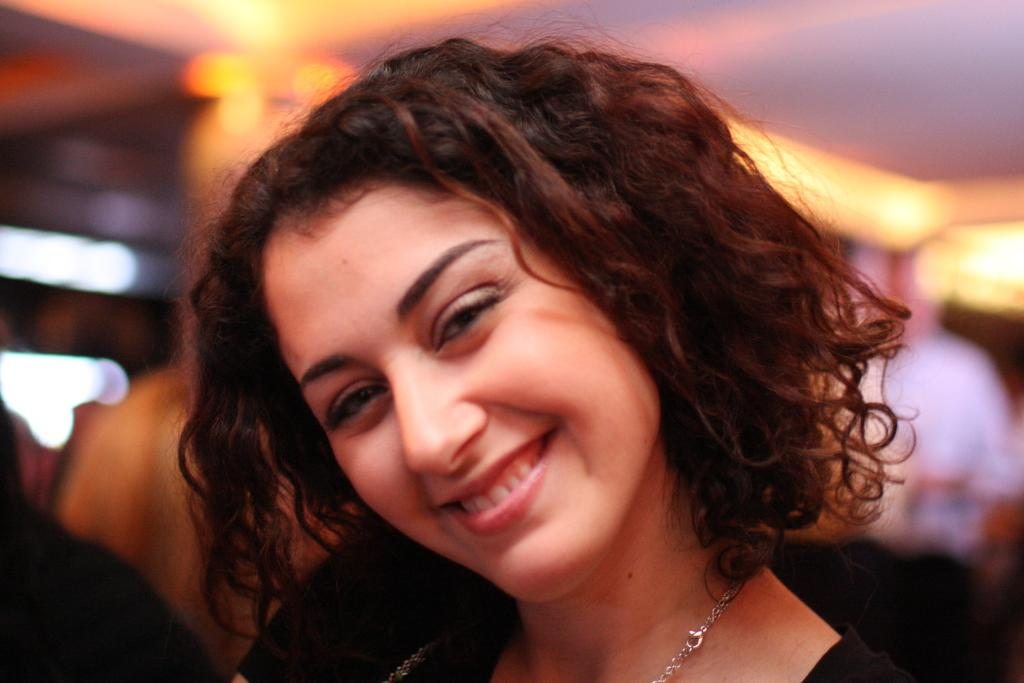Who is the main subject in the image? There is a woman in the image. What is the woman wearing? The woman is wearing a dress and a chain. What is the woman's facial expression? The woman is smiling. Can you describe the background of the image? The background of the image is blurred. What is the source of heat in the image? There is no source of heat present in the image that would generate heat. 